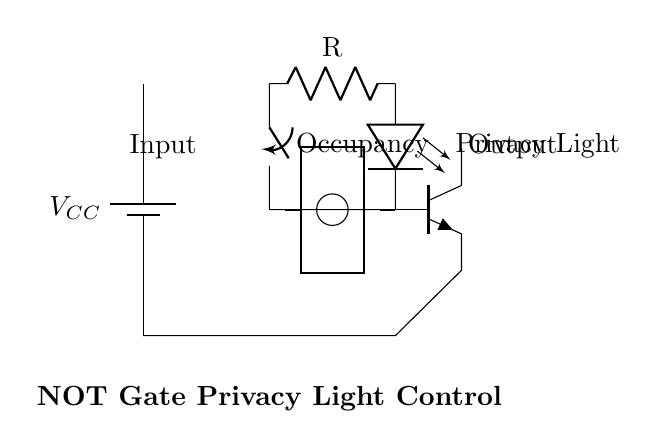What is the type of gate represented in the diagram? The gate represented in the diagram is a NOT gate, which inverts the input signal to produce the opposite output.
Answer: NOT gate What component is used to indicate the privacy light? The component that indicates the privacy light in the circuit is an LED, which lights up when the transistor is activated.
Answer: LED What is the function of the occupancy switch in this circuit? The occupancy switch serves as the input to the circuit; it determines whether the privacy light should be on or off based on its position (open or closed).
Answer: Input What is the role of the resistor in this circuit? The resistor limits the current flowing through the LED and helps to protect the LED from excess current, which can damage it.
Answer: Resistor Explain how the LED behaves when the switch is closed. When the occupancy switch is closed, the input signal to the NOT gate is high, which means the output from the NOT gate is low. Consequently, the transistor does not activate, and the LED remains off, indicating that the room is occupied.
Answer: LED off If the occupancy switch is open, what happens to the LED? With the occupancy switch open, the input to the NOT gate is low, resulting in a high output from the NOT gate. This high output activates the transistor, allowing current to flow through the LED, which lights up, indicating that the room is free.
Answer: LED on 